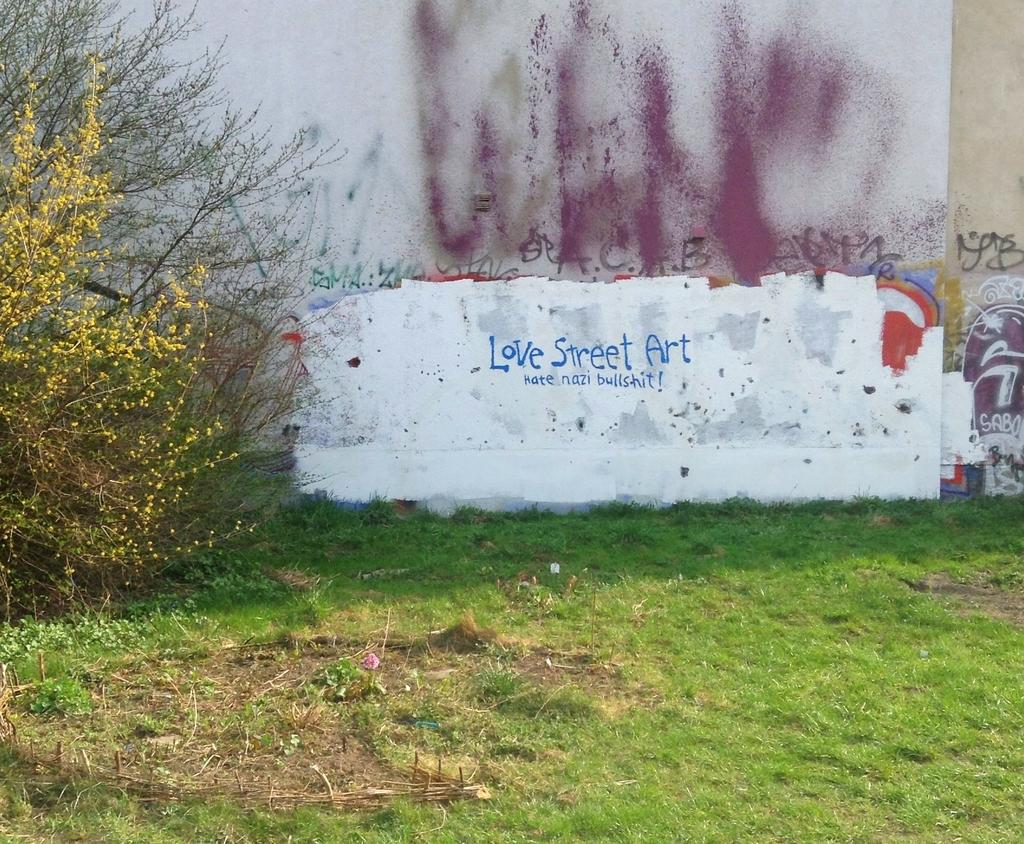What is depicted on the wall in the image? There is a wall with graffiti painting in the image. What can be seen on the left side of the image? There is a plant on the left side of the image. Where is the plant located? The plant is on grassland. Can you see a needle in the grassland in the image? There is no needle present in the image; it only features a wall with graffiti painting, a plant, and grassland. Is there a stream visible in the image? There is no stream present in the image. 